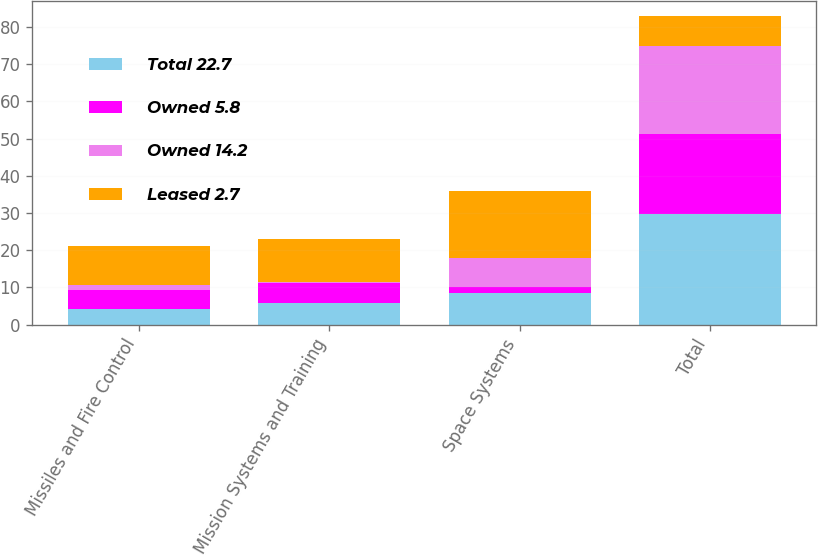Convert chart. <chart><loc_0><loc_0><loc_500><loc_500><stacked_bar_chart><ecel><fcel>Missiles and Fire Control<fcel>Mission Systems and Training<fcel>Space Systems<fcel>Total<nl><fcel>Total 22.7<fcel>4.2<fcel>5.8<fcel>8.5<fcel>29.8<nl><fcel>Owned 5.8<fcel>5.1<fcel>5.3<fcel>1.6<fcel>21.3<nl><fcel>Owned 14.2<fcel>1.3<fcel>0.4<fcel>7.9<fcel>23.8<nl><fcel>Leased 2.7<fcel>10.6<fcel>11.5<fcel>18<fcel>7.9<nl></chart> 